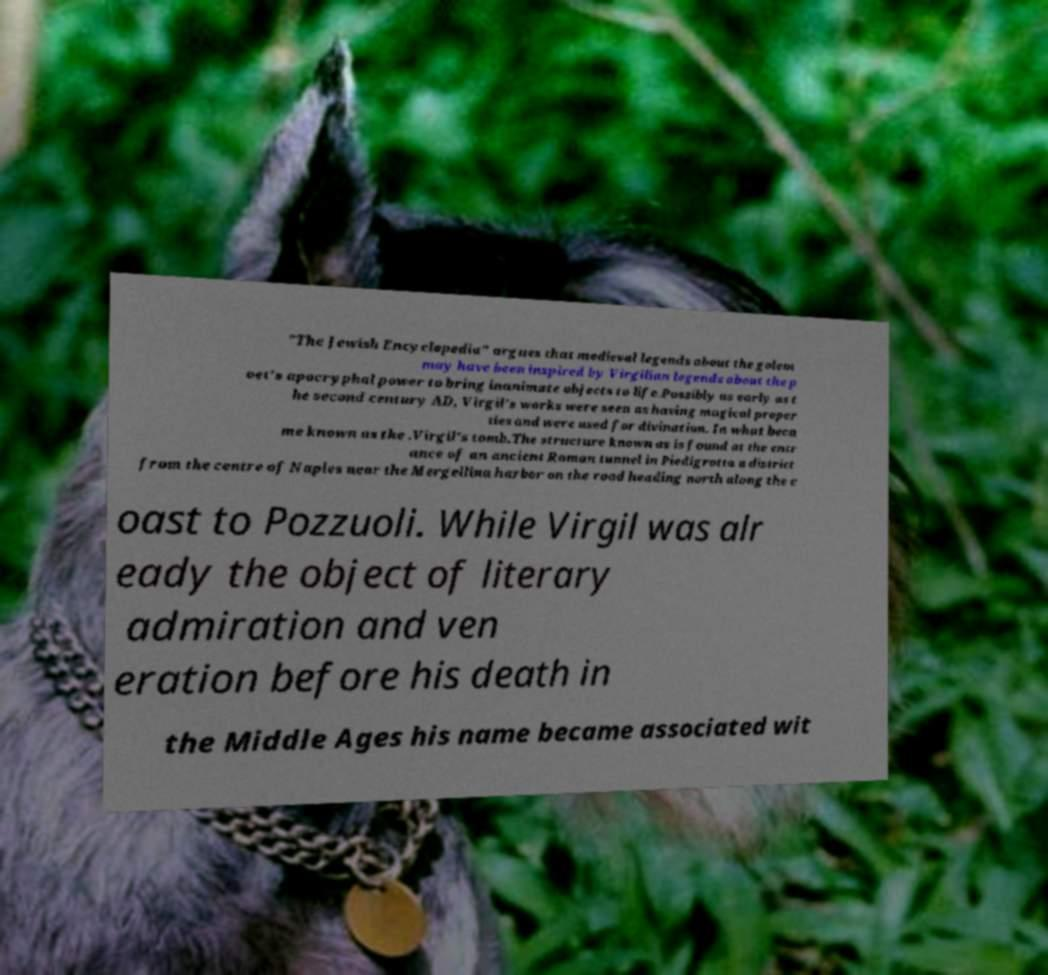What messages or text are displayed in this image? I need them in a readable, typed format. "The Jewish Encyclopedia" argues that medieval legends about the golem may have been inspired by Virgilian legends about the p oet's apocryphal power to bring inanimate objects to life.Possibly as early as t he second century AD, Virgil's works were seen as having magical proper ties and were used for divination. In what beca me known as the .Virgil's tomb.The structure known as is found at the entr ance of an ancient Roman tunnel in Piedigrotta a district from the centre of Naples near the Mergellina harbor on the road heading north along the c oast to Pozzuoli. While Virgil was alr eady the object of literary admiration and ven eration before his death in the Middle Ages his name became associated wit 